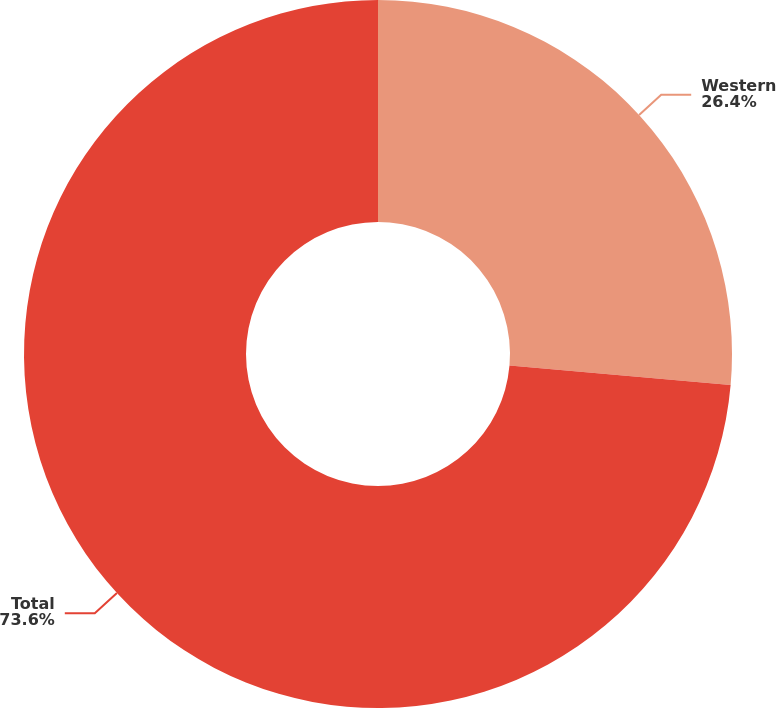Convert chart. <chart><loc_0><loc_0><loc_500><loc_500><pie_chart><fcel>Western<fcel>Total<nl><fcel>26.4%<fcel>73.6%<nl></chart> 